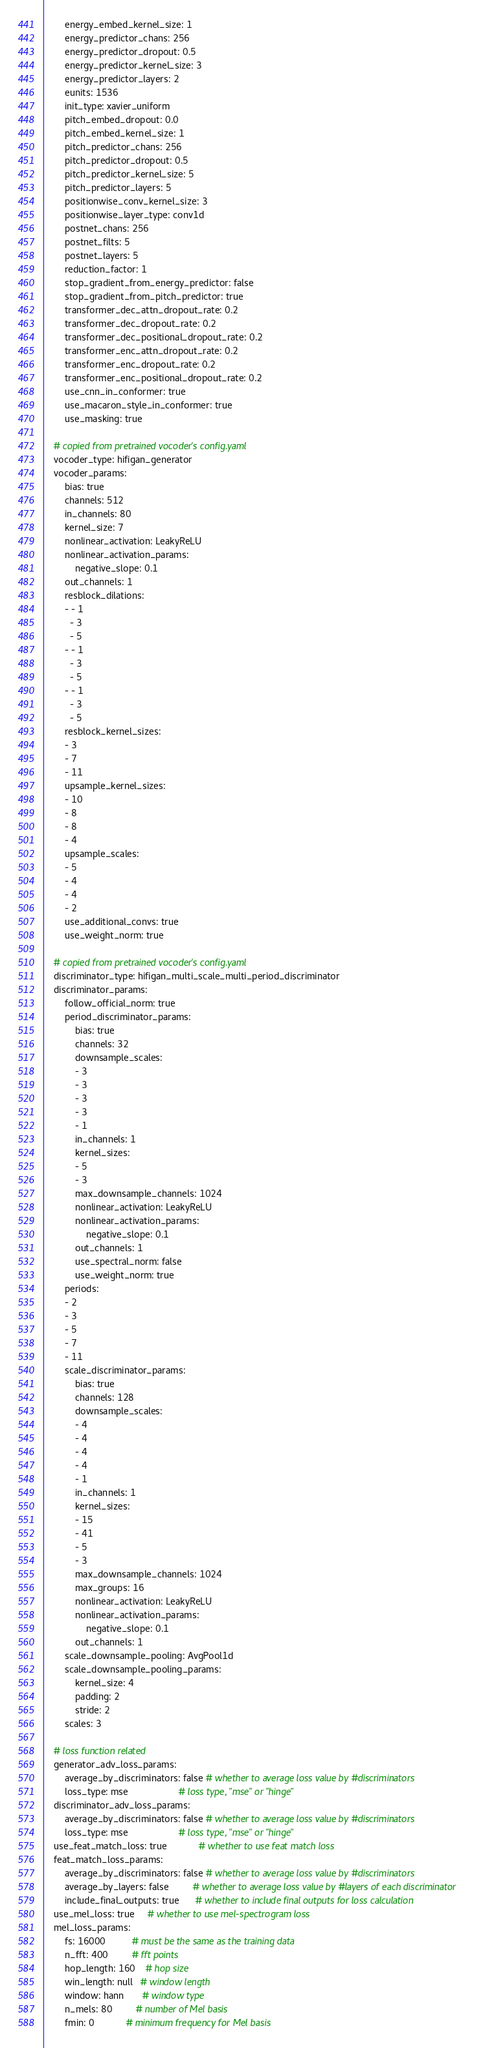Convert code to text. <code><loc_0><loc_0><loc_500><loc_500><_YAML_>        energy_embed_kernel_size: 1
        energy_predictor_chans: 256
        energy_predictor_dropout: 0.5
        energy_predictor_kernel_size: 3
        energy_predictor_layers: 2
        eunits: 1536
        init_type: xavier_uniform
        pitch_embed_dropout: 0.0
        pitch_embed_kernel_size: 1
        pitch_predictor_chans: 256
        pitch_predictor_dropout: 0.5
        pitch_predictor_kernel_size: 5
        pitch_predictor_layers: 5
        positionwise_conv_kernel_size: 3
        positionwise_layer_type: conv1d
        postnet_chans: 256
        postnet_filts: 5
        postnet_layers: 5
        reduction_factor: 1
        stop_gradient_from_energy_predictor: false
        stop_gradient_from_pitch_predictor: true
        transformer_dec_attn_dropout_rate: 0.2
        transformer_dec_dropout_rate: 0.2
        transformer_dec_positional_dropout_rate: 0.2
        transformer_enc_attn_dropout_rate: 0.2
        transformer_enc_dropout_rate: 0.2
        transformer_enc_positional_dropout_rate: 0.2
        use_cnn_in_conformer: true
        use_macaron_style_in_conformer: true
        use_masking: true

    # copied from pretrained vocoder's config.yaml
    vocoder_type: hifigan_generator
    vocoder_params:
        bias: true
        channels: 512
        in_channels: 80
        kernel_size: 7
        nonlinear_activation: LeakyReLU
        nonlinear_activation_params:
            negative_slope: 0.1
        out_channels: 1
        resblock_dilations:
        - - 1
          - 3
          - 5
        - - 1
          - 3
          - 5
        - - 1
          - 3
          - 5
        resblock_kernel_sizes:
        - 3
        - 7
        - 11
        upsample_kernel_sizes:
        - 10
        - 8
        - 8
        - 4
        upsample_scales:
        - 5
        - 4
        - 4
        - 2
        use_additional_convs: true
        use_weight_norm: true

    # copied from pretrained vocoder's config.yaml
    discriminator_type: hifigan_multi_scale_multi_period_discriminator
    discriminator_params:
        follow_official_norm: true
        period_discriminator_params:
            bias: true
            channels: 32
            downsample_scales:
            - 3
            - 3
            - 3
            - 3
            - 1
            in_channels: 1
            kernel_sizes:
            - 5
            - 3
            max_downsample_channels: 1024
            nonlinear_activation: LeakyReLU
            nonlinear_activation_params:
                negative_slope: 0.1
            out_channels: 1
            use_spectral_norm: false
            use_weight_norm: true
        periods:
        - 2
        - 3
        - 5
        - 7
        - 11
        scale_discriminator_params:
            bias: true
            channels: 128
            downsample_scales:
            - 4
            - 4
            - 4
            - 4
            - 1
            in_channels: 1
            kernel_sizes:
            - 15
            - 41
            - 5
            - 3
            max_downsample_channels: 1024
            max_groups: 16
            nonlinear_activation: LeakyReLU
            nonlinear_activation_params:
                negative_slope: 0.1
            out_channels: 1
        scale_downsample_pooling: AvgPool1d
        scale_downsample_pooling_params:
            kernel_size: 4
            padding: 2
            stride: 2
        scales: 3

    # loss function related
    generator_adv_loss_params:
        average_by_discriminators: false # whether to average loss value by #discriminators
        loss_type: mse                   # loss type, "mse" or "hinge"
    discriminator_adv_loss_params:
        average_by_discriminators: false # whether to average loss value by #discriminators
        loss_type: mse                   # loss type, "mse" or "hinge"
    use_feat_match_loss: true            # whether to use feat match loss
    feat_match_loss_params:
        average_by_discriminators: false # whether to average loss value by #discriminators
        average_by_layers: false         # whether to average loss value by #layers of each discriminator
        include_final_outputs: true      # whether to include final outputs for loss calculation
    use_mel_loss: true     # whether to use mel-spectrogram loss
    mel_loss_params:
        fs: 16000          # must be the same as the training data
        n_fft: 400         # fft points
        hop_length: 160    # hop size
        win_length: null   # window length
        window: hann       # window type
        n_mels: 80         # number of Mel basis
        fmin: 0            # minimum frequency for Mel basis</code> 